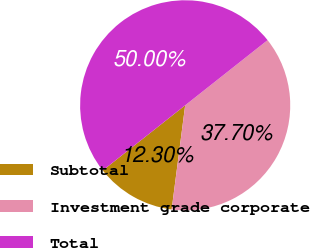Convert chart to OTSL. <chart><loc_0><loc_0><loc_500><loc_500><pie_chart><fcel>Subtotal<fcel>Investment grade corporate<fcel>Total<nl><fcel>12.3%<fcel>37.7%<fcel>50.0%<nl></chart> 